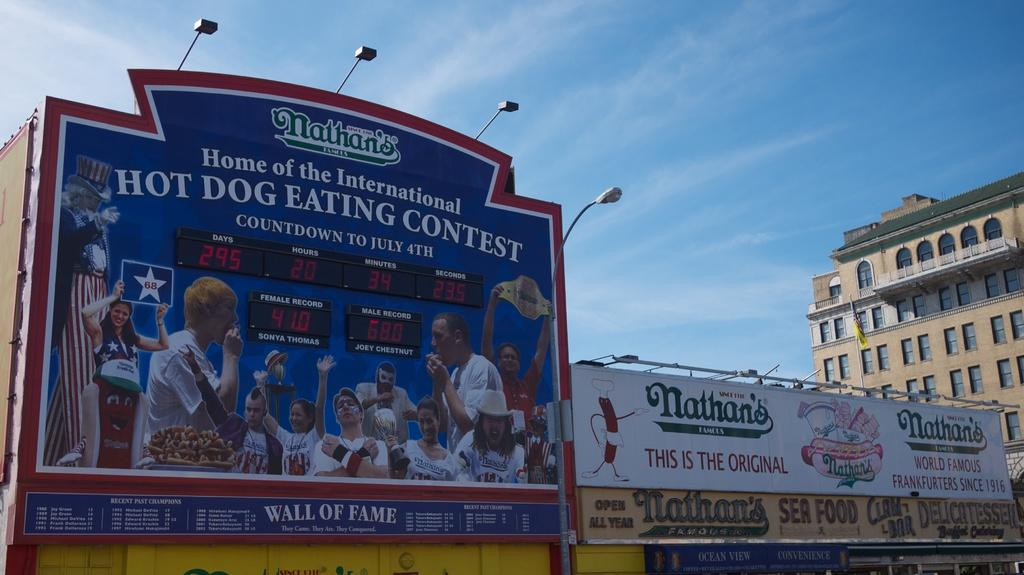<image>
Share a concise interpretation of the image provided. Several Nathan's hotdog billboards counting down to the international hot dog eating contest. 